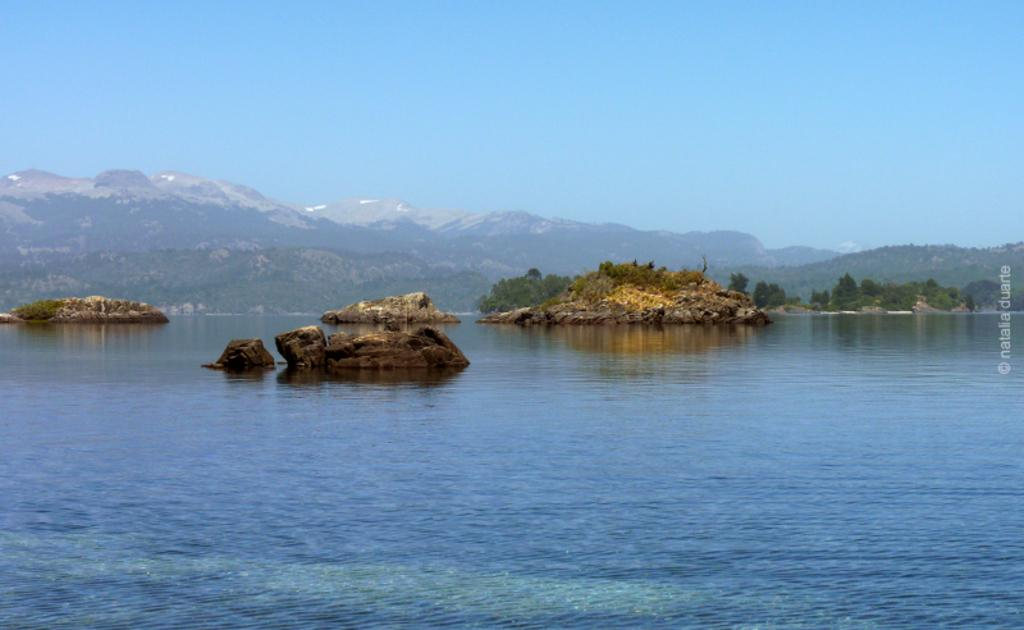What is in the water in the image? There are rocks in the water in the image. What color is the water? The water is blue. What can be seen in the background of the image? There are many trees and mountains in the background. What color is the sky in the image? The sky is blue. What type of copper object can be seen in the image? There is no copper object present in the image. What mass is the thing floating in the water? There is no thing floating in the water, only rocks are visible. 